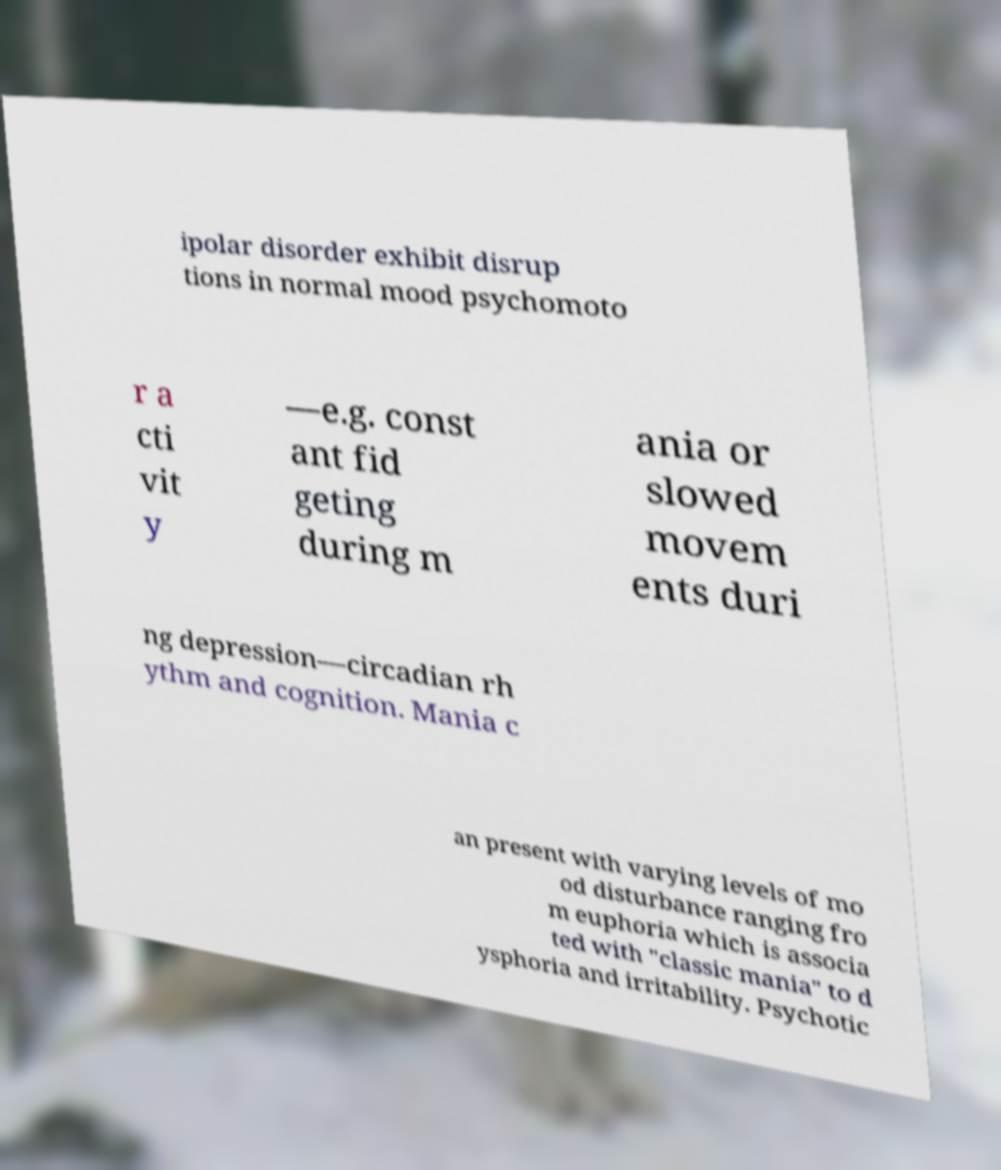For documentation purposes, I need the text within this image transcribed. Could you provide that? ipolar disorder exhibit disrup tions in normal mood psychomoto r a cti vit y —e.g. const ant fid geting during m ania or slowed movem ents duri ng depression—circadian rh ythm and cognition. Mania c an present with varying levels of mo od disturbance ranging fro m euphoria which is associa ted with "classic mania" to d ysphoria and irritability. Psychotic 